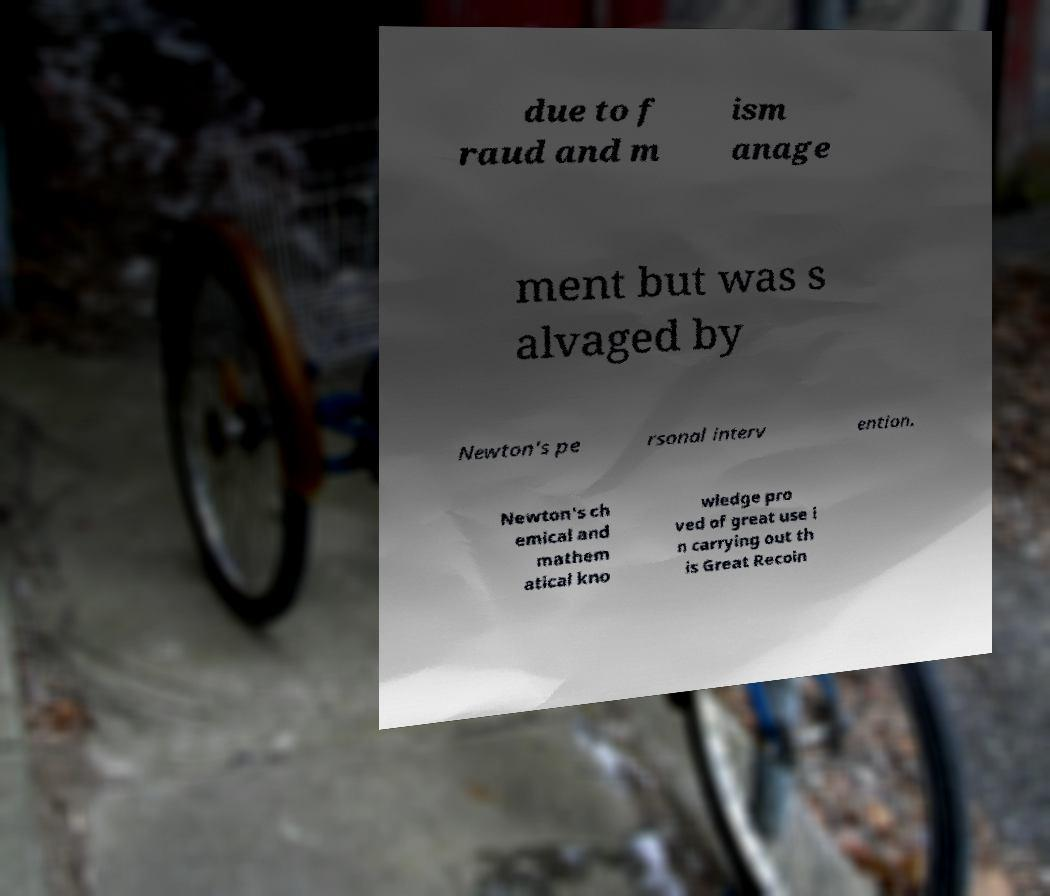I need the written content from this picture converted into text. Can you do that? due to f raud and m ism anage ment but was s alvaged by Newton's pe rsonal interv ention. Newton's ch emical and mathem atical kno wledge pro ved of great use i n carrying out th is Great Recoin 